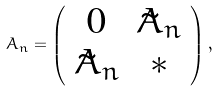Convert formula to latex. <formula><loc_0><loc_0><loc_500><loc_500>A _ { n } = \left ( \begin{array} { c c } { 0 } & { { \tilde { A } _ { n } } } \\ { { \tilde { A } _ { n } } } & { * } \end{array} \right ) ,</formula> 